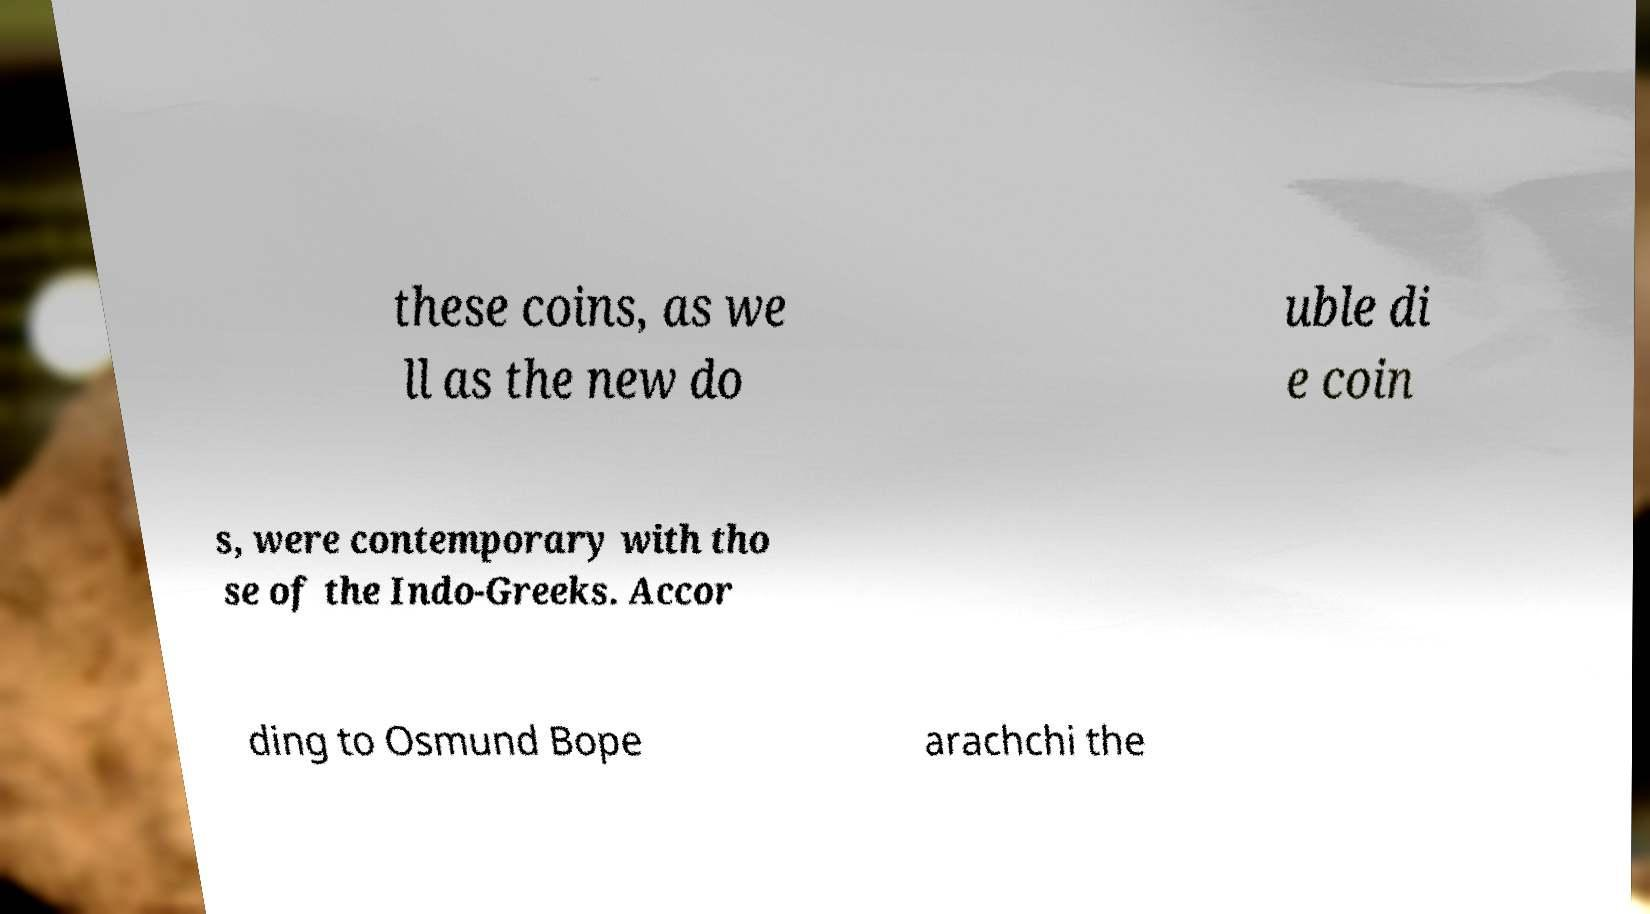Please identify and transcribe the text found in this image. these coins, as we ll as the new do uble di e coin s, were contemporary with tho se of the Indo-Greeks. Accor ding to Osmund Bope arachchi the 